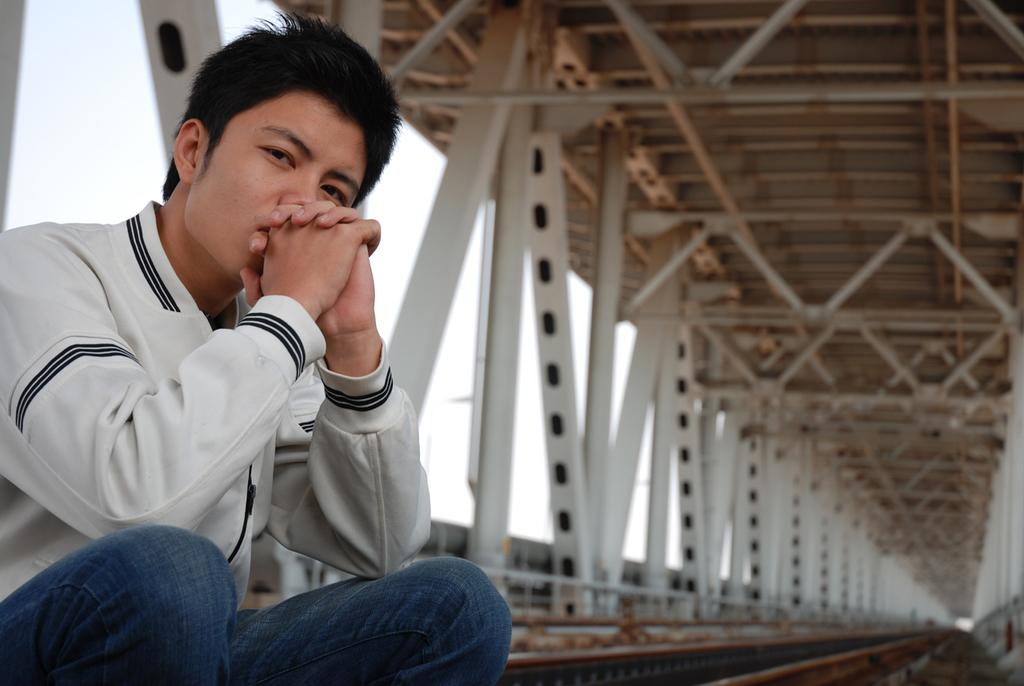What is the main subject of the image? There is a person in the image. What is the person wearing? The person is wearing a white shirt and blue jeans. Where is the person located in the image? The person is sitting on a bridge. Can you see any snails crawling on the person's white shirt in the image? There are no snails visible on the person's white shirt in the image. What type of berry is being used as a decoration on the bridge in the image? There are no berries present in the image, as it features a person sitting on a bridge wearing a white shirt and blue jeans. 